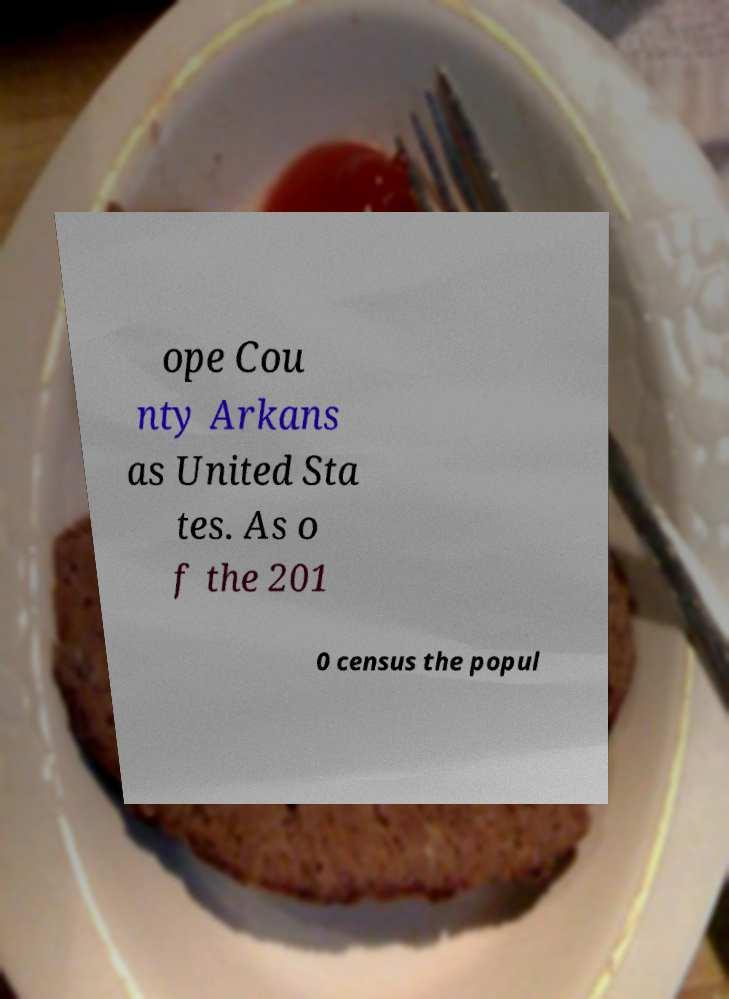Please read and relay the text visible in this image. What does it say? ope Cou nty Arkans as United Sta tes. As o f the 201 0 census the popul 